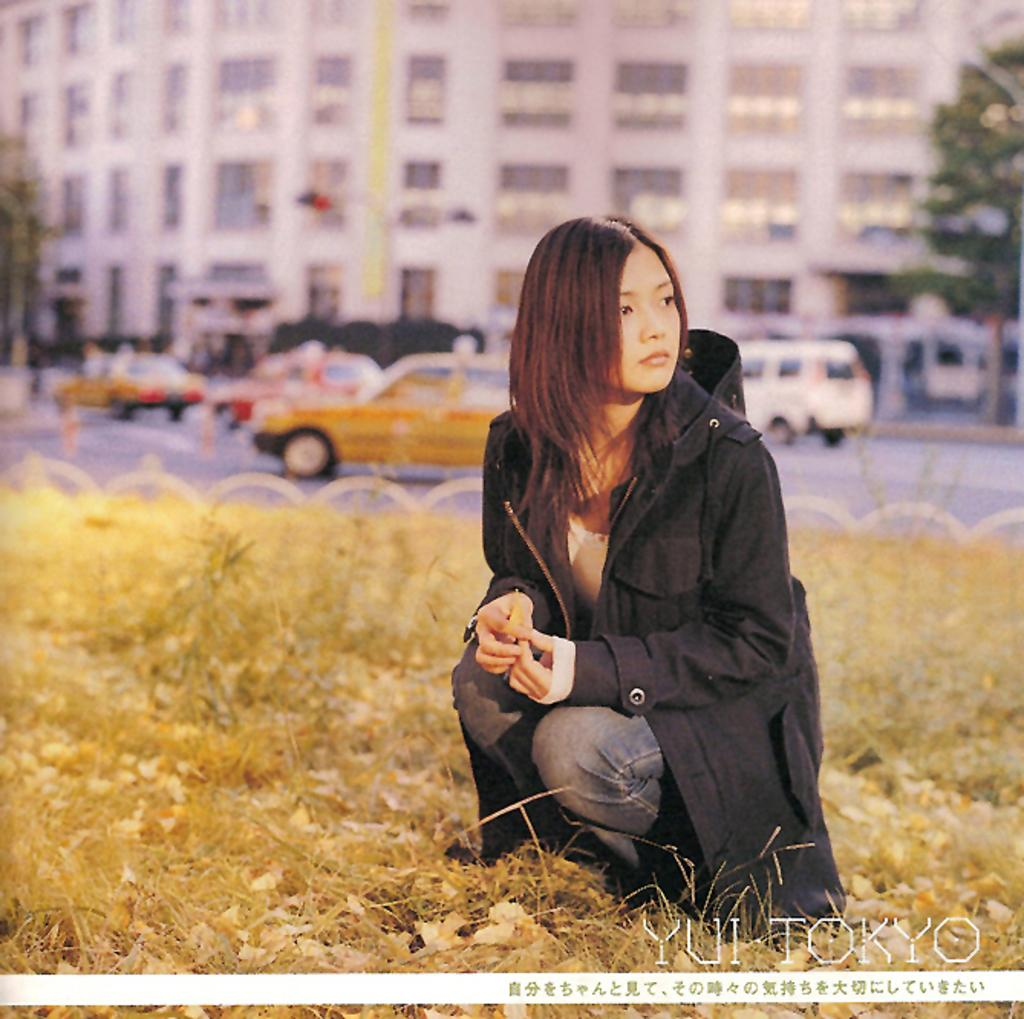What type of vegetation can be seen in the image? There is dry grass in the image. What is the woman wearing in the image? The woman is wearing a black jacket in the image. What else can be seen in the image besides the woman and dry grass? Vehicles, a building, and a tree are present in the image. Where is the nut being stored in the image? There is no nut present in the image. How does the basin help with the woman's activities in the image? There is no basin present in the image, so it cannot help with the woman's activities. 